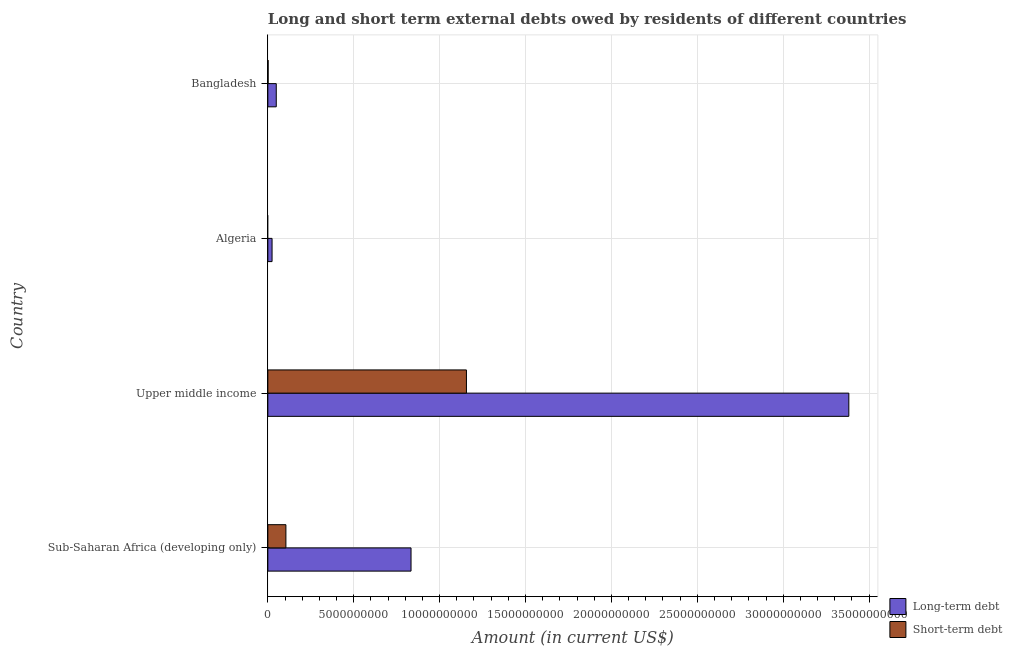How many different coloured bars are there?
Your answer should be very brief. 2. Are the number of bars per tick equal to the number of legend labels?
Ensure brevity in your answer.  No. How many bars are there on the 1st tick from the bottom?
Keep it short and to the point. 2. What is the label of the 3rd group of bars from the top?
Keep it short and to the point. Upper middle income. In how many cases, is the number of bars for a given country not equal to the number of legend labels?
Provide a succinct answer. 1. Across all countries, what is the maximum long-term debts owed by residents?
Make the answer very short. 3.38e+1. Across all countries, what is the minimum short-term debts owed by residents?
Offer a terse response. 0. In which country was the short-term debts owed by residents maximum?
Make the answer very short. Upper middle income. What is the total long-term debts owed by residents in the graph?
Offer a terse response. 4.29e+1. What is the difference between the long-term debts owed by residents in Sub-Saharan Africa (developing only) and that in Upper middle income?
Provide a short and direct response. -2.55e+1. What is the difference between the long-term debts owed by residents in Upper middle income and the short-term debts owed by residents in Algeria?
Offer a terse response. 3.38e+1. What is the average long-term debts owed by residents per country?
Give a very brief answer. 1.07e+1. What is the difference between the short-term debts owed by residents and long-term debts owed by residents in Upper middle income?
Offer a very short reply. -2.23e+1. What is the ratio of the short-term debts owed by residents in Bangladesh to that in Upper middle income?
Keep it short and to the point. 0. What is the difference between the highest and the second highest short-term debts owed by residents?
Keep it short and to the point. 1.05e+1. What is the difference between the highest and the lowest short-term debts owed by residents?
Offer a terse response. 1.16e+1. In how many countries, is the long-term debts owed by residents greater than the average long-term debts owed by residents taken over all countries?
Keep it short and to the point. 1. What is the difference between two consecutive major ticks on the X-axis?
Keep it short and to the point. 5.00e+09. Are the values on the major ticks of X-axis written in scientific E-notation?
Provide a succinct answer. No. How are the legend labels stacked?
Keep it short and to the point. Vertical. What is the title of the graph?
Provide a short and direct response. Long and short term external debts owed by residents of different countries. Does "Net National savings" appear as one of the legend labels in the graph?
Your response must be concise. No. What is the label or title of the Y-axis?
Provide a short and direct response. Country. What is the Amount (in current US$) in Long-term debt in Sub-Saharan Africa (developing only)?
Your answer should be compact. 8.34e+09. What is the Amount (in current US$) of Short-term debt in Sub-Saharan Africa (developing only)?
Offer a very short reply. 1.05e+09. What is the Amount (in current US$) of Long-term debt in Upper middle income?
Offer a very short reply. 3.38e+1. What is the Amount (in current US$) of Short-term debt in Upper middle income?
Make the answer very short. 1.16e+1. What is the Amount (in current US$) of Long-term debt in Algeria?
Your response must be concise. 2.45e+08. What is the Amount (in current US$) in Short-term debt in Algeria?
Make the answer very short. 0. What is the Amount (in current US$) of Long-term debt in Bangladesh?
Offer a terse response. 4.90e+08. What is the Amount (in current US$) in Short-term debt in Bangladesh?
Make the answer very short. 1.60e+07. Across all countries, what is the maximum Amount (in current US$) of Long-term debt?
Your answer should be very brief. 3.38e+1. Across all countries, what is the maximum Amount (in current US$) in Short-term debt?
Provide a short and direct response. 1.16e+1. Across all countries, what is the minimum Amount (in current US$) in Long-term debt?
Ensure brevity in your answer.  2.45e+08. Across all countries, what is the minimum Amount (in current US$) of Short-term debt?
Provide a succinct answer. 0. What is the total Amount (in current US$) in Long-term debt in the graph?
Your answer should be compact. 4.29e+1. What is the total Amount (in current US$) of Short-term debt in the graph?
Your answer should be very brief. 1.26e+1. What is the difference between the Amount (in current US$) in Long-term debt in Sub-Saharan Africa (developing only) and that in Upper middle income?
Give a very brief answer. -2.55e+1. What is the difference between the Amount (in current US$) in Short-term debt in Sub-Saharan Africa (developing only) and that in Upper middle income?
Provide a succinct answer. -1.05e+1. What is the difference between the Amount (in current US$) in Long-term debt in Sub-Saharan Africa (developing only) and that in Algeria?
Make the answer very short. 8.09e+09. What is the difference between the Amount (in current US$) of Long-term debt in Sub-Saharan Africa (developing only) and that in Bangladesh?
Ensure brevity in your answer.  7.85e+09. What is the difference between the Amount (in current US$) in Short-term debt in Sub-Saharan Africa (developing only) and that in Bangladesh?
Offer a very short reply. 1.04e+09. What is the difference between the Amount (in current US$) in Long-term debt in Upper middle income and that in Algeria?
Your response must be concise. 3.36e+1. What is the difference between the Amount (in current US$) in Long-term debt in Upper middle income and that in Bangladesh?
Offer a very short reply. 3.33e+1. What is the difference between the Amount (in current US$) of Short-term debt in Upper middle income and that in Bangladesh?
Your answer should be compact. 1.15e+1. What is the difference between the Amount (in current US$) in Long-term debt in Algeria and that in Bangladesh?
Provide a short and direct response. -2.45e+08. What is the difference between the Amount (in current US$) in Long-term debt in Sub-Saharan Africa (developing only) and the Amount (in current US$) in Short-term debt in Upper middle income?
Your answer should be very brief. -3.23e+09. What is the difference between the Amount (in current US$) in Long-term debt in Sub-Saharan Africa (developing only) and the Amount (in current US$) in Short-term debt in Bangladesh?
Keep it short and to the point. 8.32e+09. What is the difference between the Amount (in current US$) of Long-term debt in Upper middle income and the Amount (in current US$) of Short-term debt in Bangladesh?
Provide a succinct answer. 3.38e+1. What is the difference between the Amount (in current US$) in Long-term debt in Algeria and the Amount (in current US$) in Short-term debt in Bangladesh?
Offer a very short reply. 2.29e+08. What is the average Amount (in current US$) of Long-term debt per country?
Keep it short and to the point. 1.07e+1. What is the average Amount (in current US$) in Short-term debt per country?
Provide a short and direct response. 3.16e+09. What is the difference between the Amount (in current US$) of Long-term debt and Amount (in current US$) of Short-term debt in Sub-Saharan Africa (developing only)?
Your response must be concise. 7.28e+09. What is the difference between the Amount (in current US$) of Long-term debt and Amount (in current US$) of Short-term debt in Upper middle income?
Ensure brevity in your answer.  2.23e+1. What is the difference between the Amount (in current US$) of Long-term debt and Amount (in current US$) of Short-term debt in Bangladesh?
Your response must be concise. 4.74e+08. What is the ratio of the Amount (in current US$) in Long-term debt in Sub-Saharan Africa (developing only) to that in Upper middle income?
Provide a succinct answer. 0.25. What is the ratio of the Amount (in current US$) of Short-term debt in Sub-Saharan Africa (developing only) to that in Upper middle income?
Ensure brevity in your answer.  0.09. What is the ratio of the Amount (in current US$) of Long-term debt in Sub-Saharan Africa (developing only) to that in Algeria?
Provide a short and direct response. 33.98. What is the ratio of the Amount (in current US$) of Long-term debt in Sub-Saharan Africa (developing only) to that in Bangladesh?
Offer a very short reply. 17.01. What is the ratio of the Amount (in current US$) of Short-term debt in Sub-Saharan Africa (developing only) to that in Bangladesh?
Give a very brief answer. 65.7. What is the ratio of the Amount (in current US$) in Long-term debt in Upper middle income to that in Algeria?
Ensure brevity in your answer.  137.9. What is the ratio of the Amount (in current US$) of Long-term debt in Upper middle income to that in Bangladesh?
Your response must be concise. 69.04. What is the ratio of the Amount (in current US$) of Short-term debt in Upper middle income to that in Bangladesh?
Offer a terse response. 722.58. What is the ratio of the Amount (in current US$) of Long-term debt in Algeria to that in Bangladesh?
Make the answer very short. 0.5. What is the difference between the highest and the second highest Amount (in current US$) in Long-term debt?
Offer a very short reply. 2.55e+1. What is the difference between the highest and the second highest Amount (in current US$) of Short-term debt?
Provide a short and direct response. 1.05e+1. What is the difference between the highest and the lowest Amount (in current US$) in Long-term debt?
Offer a very short reply. 3.36e+1. What is the difference between the highest and the lowest Amount (in current US$) in Short-term debt?
Give a very brief answer. 1.16e+1. 